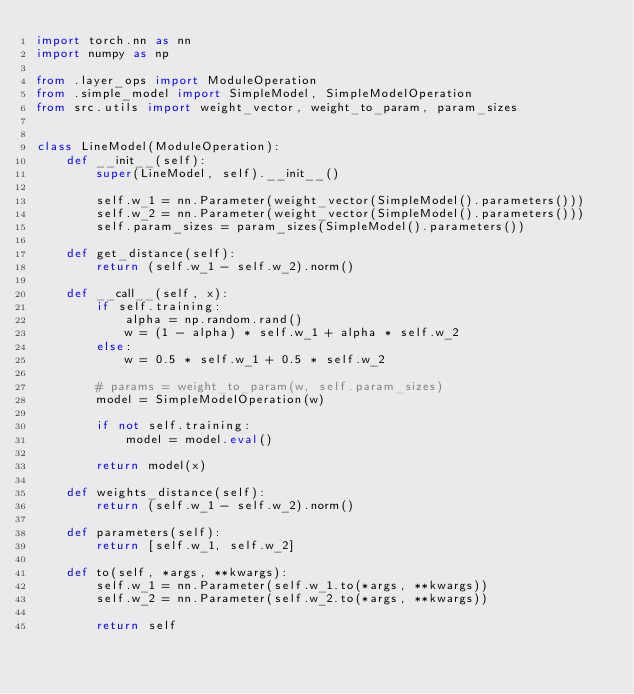<code> <loc_0><loc_0><loc_500><loc_500><_Python_>import torch.nn as nn
import numpy as np

from .layer_ops import ModuleOperation
from .simple_model import SimpleModel, SimpleModelOperation
from src.utils import weight_vector, weight_to_param, param_sizes


class LineModel(ModuleOperation):
    def __init__(self):
        super(LineModel, self).__init__()

        self.w_1 = nn.Parameter(weight_vector(SimpleModel().parameters()))
        self.w_2 = nn.Parameter(weight_vector(SimpleModel().parameters()))
        self.param_sizes = param_sizes(SimpleModel().parameters())

    def get_distance(self):
        return (self.w_1 - self.w_2).norm()

    def __call__(self, x):
        if self.training:
            alpha = np.random.rand()
            w = (1 - alpha) * self.w_1 + alpha * self.w_2
        else:
            w = 0.5 * self.w_1 + 0.5 * self.w_2

        # params = weight_to_param(w, self.param_sizes)
        model = SimpleModelOperation(w)

        if not self.training:
            model = model.eval()

        return model(x)

    def weights_distance(self):
        return (self.w_1 - self.w_2).norm()

    def parameters(self):
        return [self.w_1, self.w_2]

    def to(self, *args, **kwargs):
        self.w_1 = nn.Parameter(self.w_1.to(*args, **kwargs))
        self.w_2 = nn.Parameter(self.w_2.to(*args, **kwargs))

        return self
</code> 